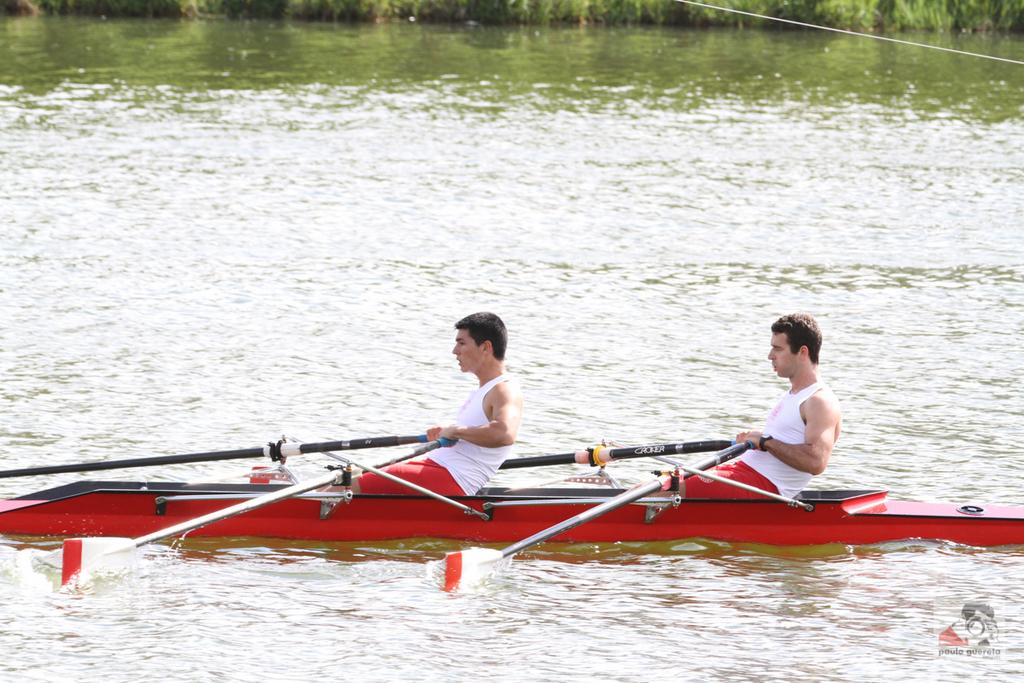How many people are in the image? There are two persons in the image. What are the two persons doing in the image? The two persons are rowing a boat. Where is the boat located in the image? The boat is in the water. What type of vegetation can be seen at the back side of the image? There is grass on the surface at the back side of the image. What type of beef is being discussed by the two persons in the image? There is no beef or discussion about beef present in the image. 